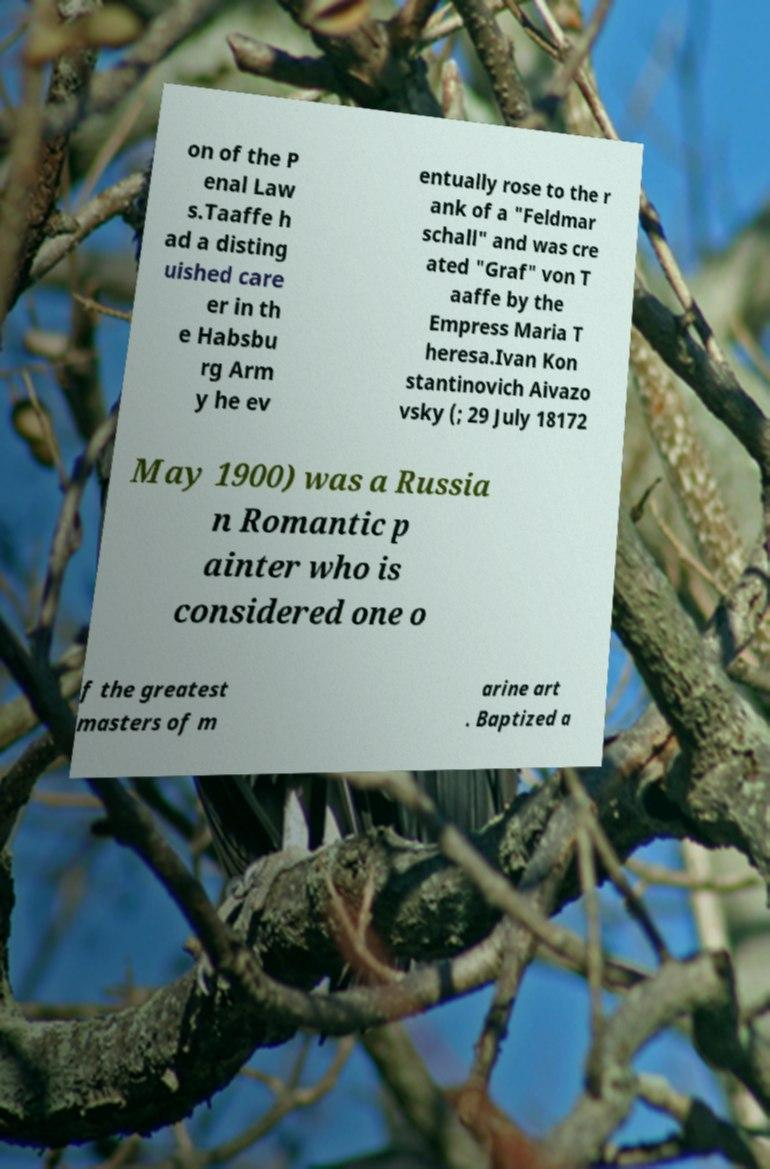There's text embedded in this image that I need extracted. Can you transcribe it verbatim? on of the P enal Law s.Taaffe h ad a disting uished care er in th e Habsbu rg Arm y he ev entually rose to the r ank of a "Feldmar schall" and was cre ated "Graf" von T aaffe by the Empress Maria T heresa.Ivan Kon stantinovich Aivazo vsky (; 29 July 18172 May 1900) was a Russia n Romantic p ainter who is considered one o f the greatest masters of m arine art . Baptized a 